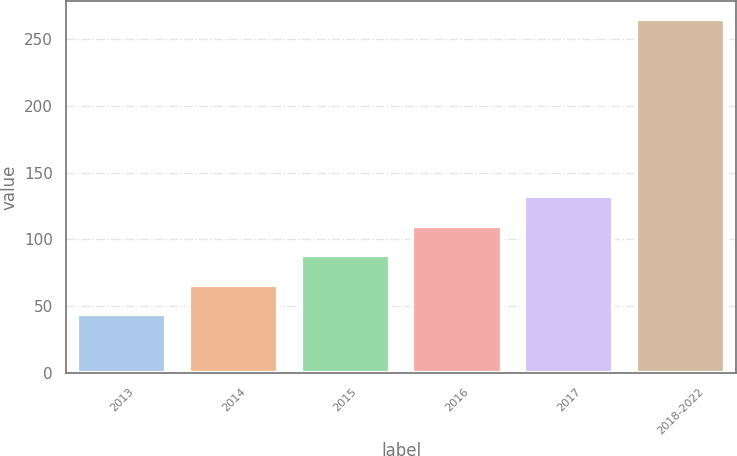<chart> <loc_0><loc_0><loc_500><loc_500><bar_chart><fcel>2013<fcel>2014<fcel>2015<fcel>2016<fcel>2017<fcel>2018-2022<nl><fcel>44<fcel>66.1<fcel>88.2<fcel>110.3<fcel>132.4<fcel>265<nl></chart> 